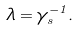<formula> <loc_0><loc_0><loc_500><loc_500>\lambda = \gamma _ { s } ^ { - 1 } .</formula> 